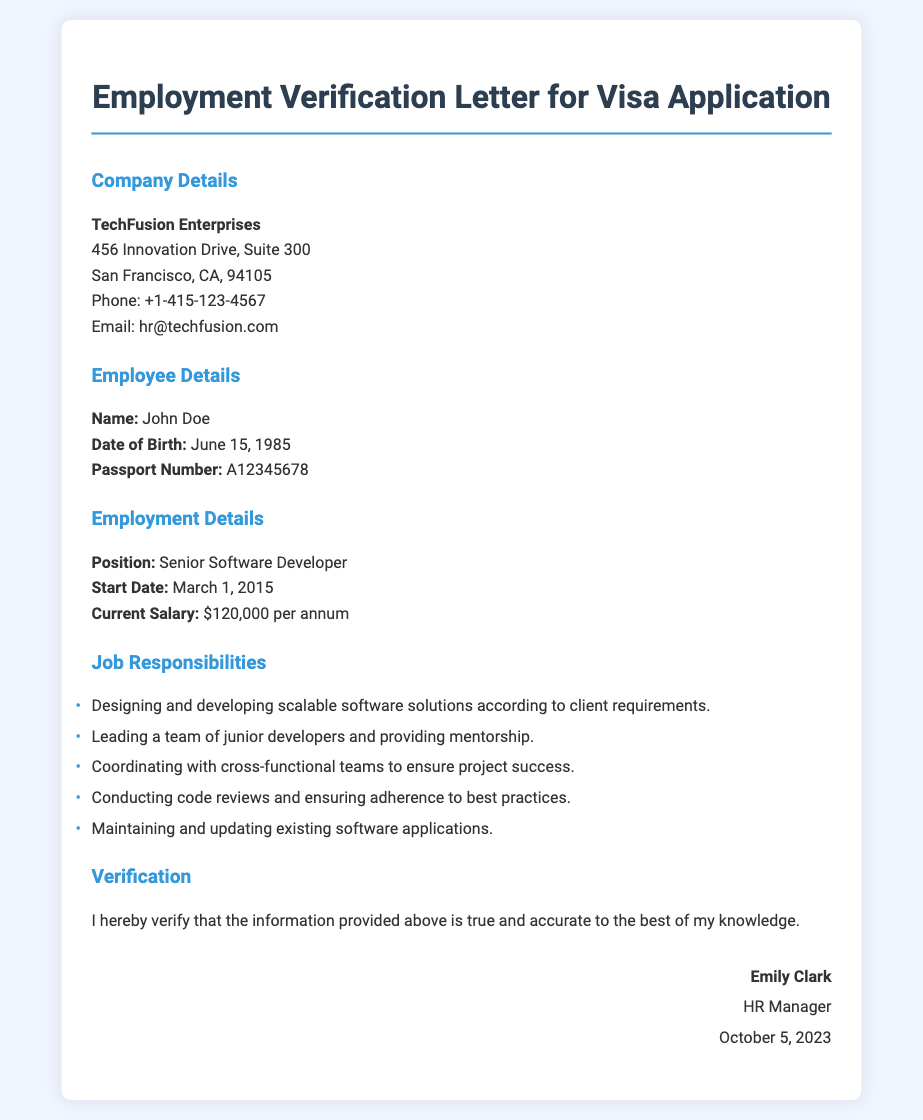What is the employee's name? The employee's name is provided in the "Employee Details" section of the document.
Answer: John Doe What is the current salary? The current salary is mentioned in the "Employment Details" section.
Answer: $120,000 per annum What is the position held by the employee? The employee's position is listed in the "Employment Details" section.
Answer: Senior Software Developer What is the start date of employment? The start date is specified in the "Employment Details" section of the document.
Answer: March 1, 2015 How many job responsibilities are listed? The number of job responsibilities can be counted in the "Job Responsibilities" section.
Answer: Five Who is the HR Manager's name? The HR Manager's name is found in the "Verification" section at the end of the document.
Answer: Emily Clark What is the date of the verification? The date of verification is stated in the "Verification" section.
Answer: October 5, 2023 What is the company name? The company name is mentioned in the "Company Details" section.
Answer: TechFusion Enterprises What type of letter is this? The type of document is indicated in the title and throughout the content.
Answer: Employment Verification Letter for Visa Application 